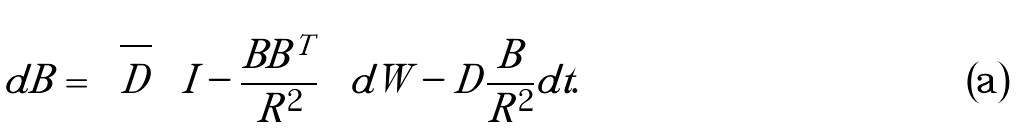<formula> <loc_0><loc_0><loc_500><loc_500>d B = \sqrt { D } \left ( I - \frac { B B ^ { T } } { R ^ { 2 } } \right ) d W - D \frac { B } { R ^ { 2 } } d t .</formula> 